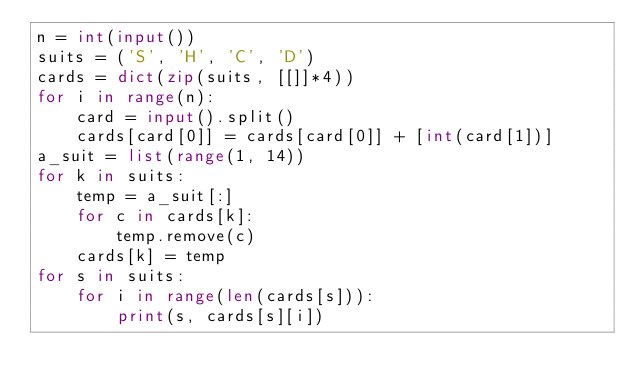Convert code to text. <code><loc_0><loc_0><loc_500><loc_500><_Python_>n = int(input())
suits = ('S', 'H', 'C', 'D')
cards = dict(zip(suits, [[]]*4))
for i in range(n):
    card = input().split()
    cards[card[0]] = cards[card[0]] + [int(card[1])]
a_suit = list(range(1, 14))
for k in suits:
    temp = a_suit[:]
    for c in cards[k]:
        temp.remove(c)
    cards[k] = temp
for s in suits:
    for i in range(len(cards[s])):
        print(s, cards[s][i])
</code> 